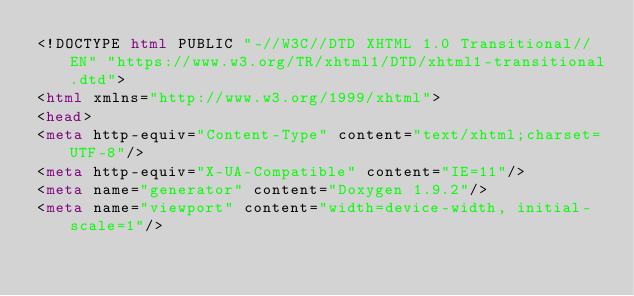Convert code to text. <code><loc_0><loc_0><loc_500><loc_500><_HTML_><!DOCTYPE html PUBLIC "-//W3C//DTD XHTML 1.0 Transitional//EN" "https://www.w3.org/TR/xhtml1/DTD/xhtml1-transitional.dtd">
<html xmlns="http://www.w3.org/1999/xhtml">
<head>
<meta http-equiv="Content-Type" content="text/xhtml;charset=UTF-8"/>
<meta http-equiv="X-UA-Compatible" content="IE=11"/>
<meta name="generator" content="Doxygen 1.9.2"/>
<meta name="viewport" content="width=device-width, initial-scale=1"/></code> 